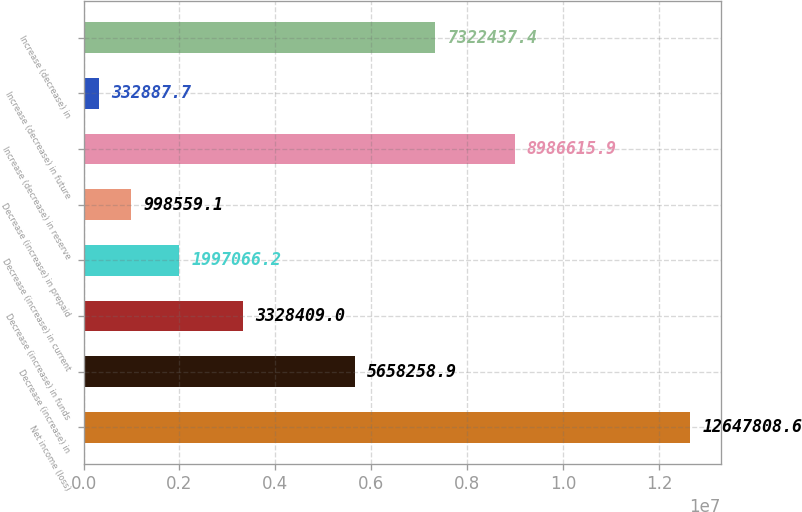Convert chart to OTSL. <chart><loc_0><loc_0><loc_500><loc_500><bar_chart><fcel>Net income (loss)<fcel>Decrease (increase) in<fcel>Decrease (increase) in funds<fcel>Decrease (increase) in current<fcel>Decrease (increase) in prepaid<fcel>Increase (decrease) in reserve<fcel>Increase (decrease) in future<fcel>Increase (decrease) in<nl><fcel>1.26478e+07<fcel>5.65826e+06<fcel>3.32841e+06<fcel>1.99707e+06<fcel>998559<fcel>8.98662e+06<fcel>332888<fcel>7.32244e+06<nl></chart> 